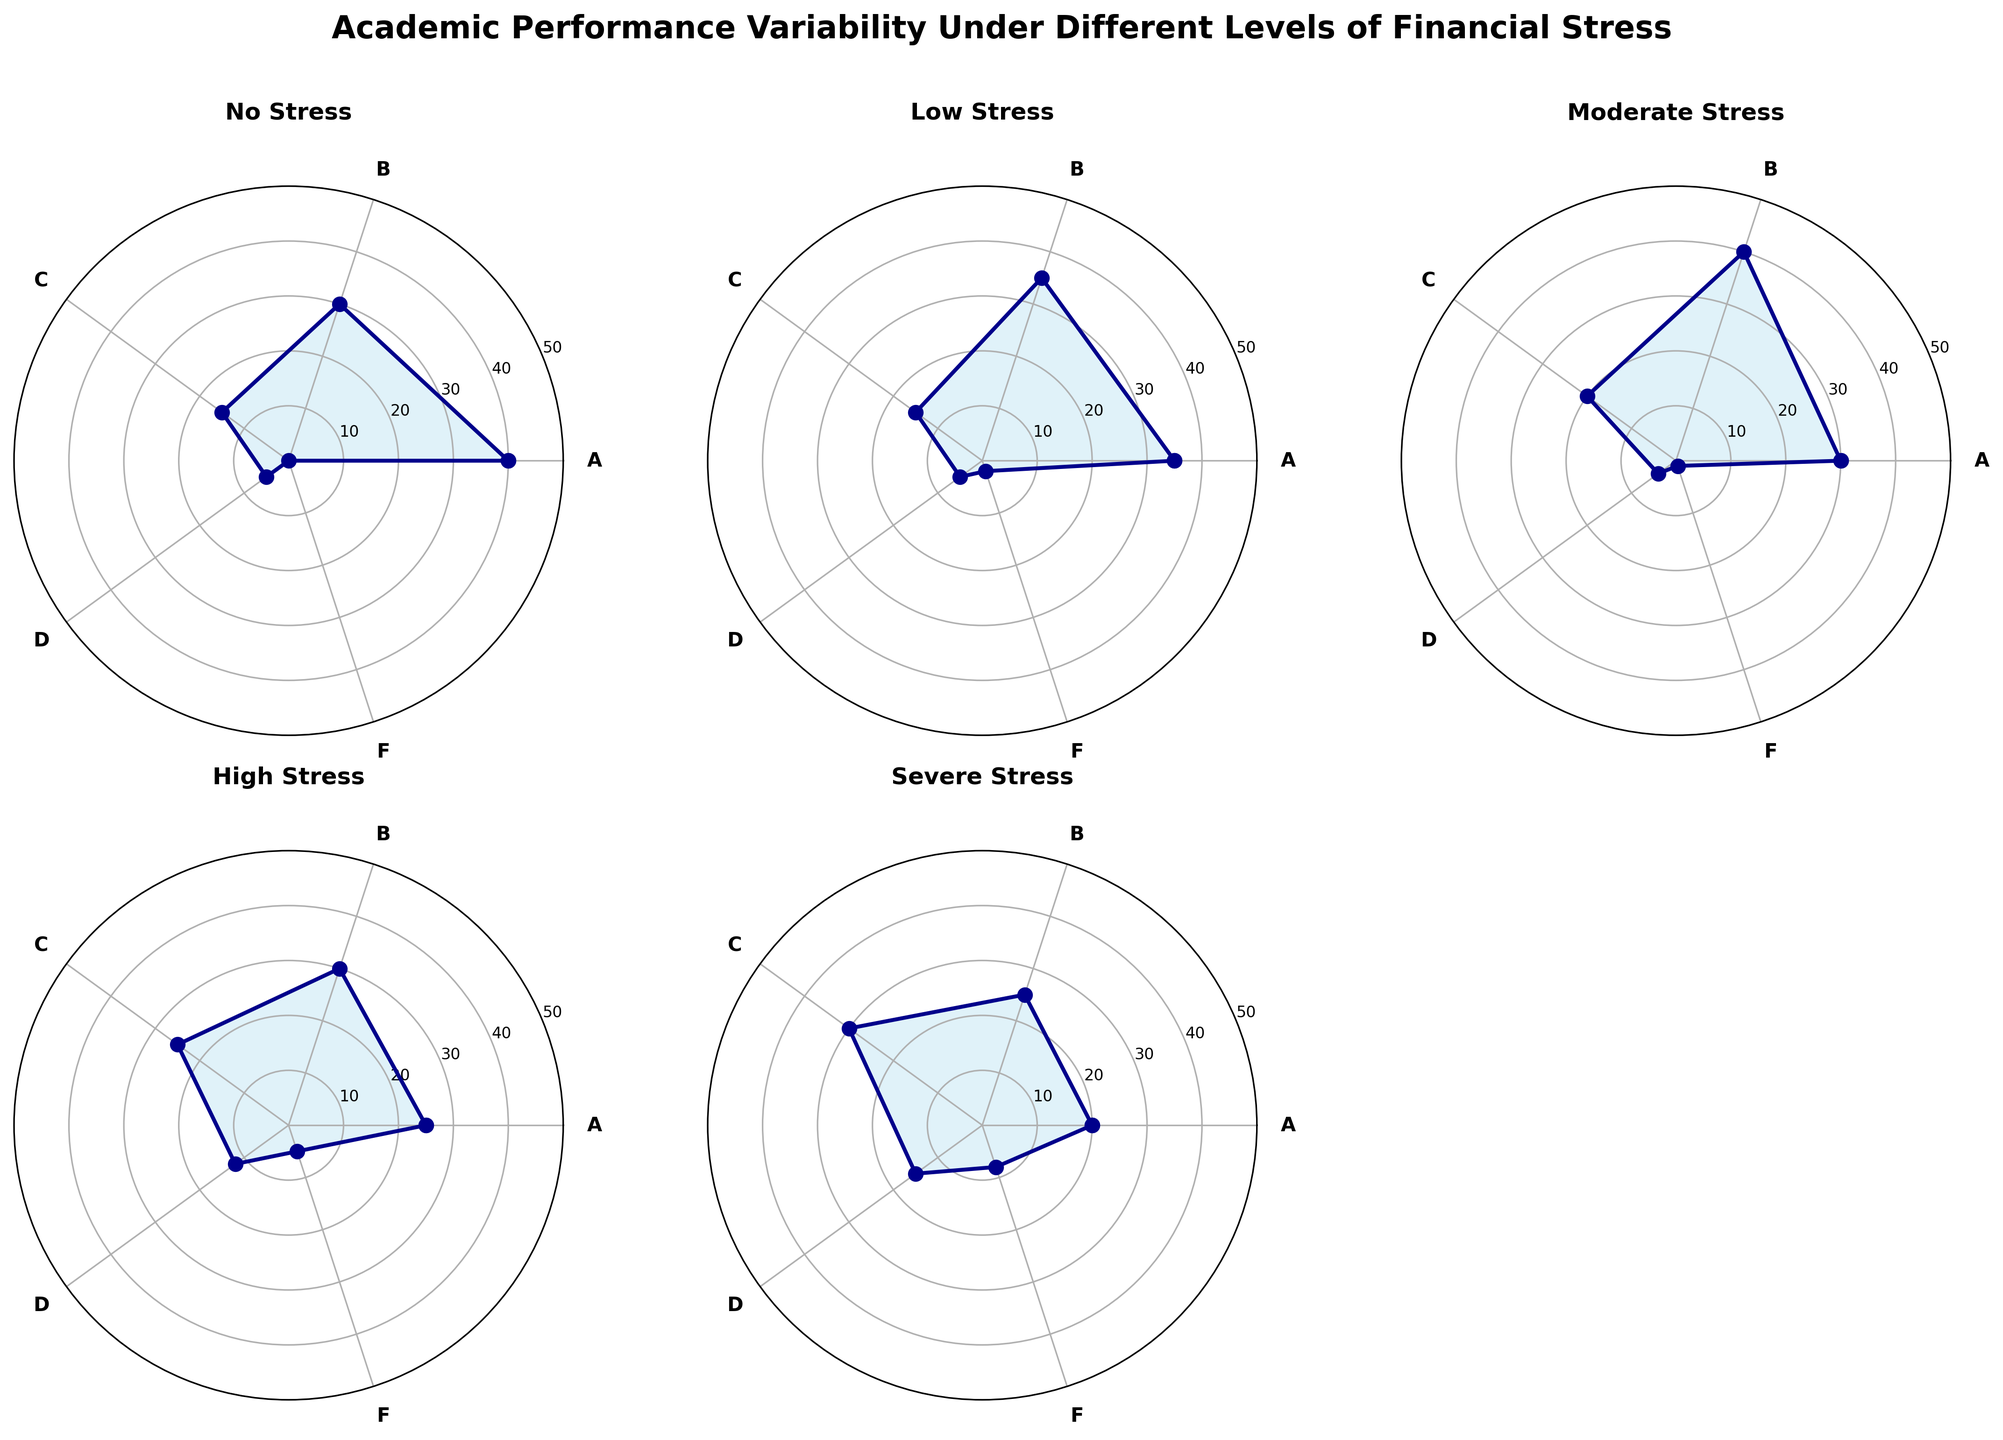What is the title of the figure? The title of the figure is centered at the top and describes the content of the plot.
Answer: Academic Performance Variability Under Different Levels of Financial Stress Which stress level corresponds to the highest proportion of grade A? Look at the 'A' section for each rose chart and identify which has the largest value.
Answer: No Stress How does the proportion of students receiving grade D change as financial stress increases? Check the values in the D segment across the different stress levels, starting from No Stress to Severe Stress.
Answer: Increases What is the sum of students receiving grade B across all stress levels? Add the values in the B column for all stress levels: 40 (No Stress) + 35 (Low Stress) + 30 (Moderate Stress) + 25 (High Stress) + 20 (Severe Stress) = 150.
Answer: 150 Which financial stress level has the lowest percentage of students receiving grade F? Look for the smallest value in the F category across all stress levels.
Answer: No Stress Compare the proportion of grade C students in Moderate Stress and High Stress. Which is higher? Look at the C grades for Moderate (40) and High (30) stress levels and compare them.
Answer: Moderate Stress How does the distribution of grades under Low Stress compare to Moderate Stress? Check the grade distributions for Low Stress: A-8, B-35, C-35, D-15, F-2 and Moderate Stress: A-5, B-30, C-40, D-20, F-1. Identify similarities and differences.
Answer: Low Stress has more A and B, fewer C, fewer D, and more F compared to Moderate Stress What is the range of students receiving grade F between the No Stress and Severe Stress levels? Find the difference between the F values in No Stress (0) and Severe Stress (8).
Answer: 8 Which grade shows the most significant decrease from No Stress to Severe Stress? Compare the changes in all grades from No Stress to Severe Stress: A decreases by 8, B by 20, C by 5, D decreases by 15, and F increases by 8.
Answer: B What can we infer about the academic performance trend as financial stress increases? Overall, higher financial stress corresponds to decreased higher grades (A, B) and increased lower grades (D, F), indicating worsening academic performance.
Answer: Worsens 